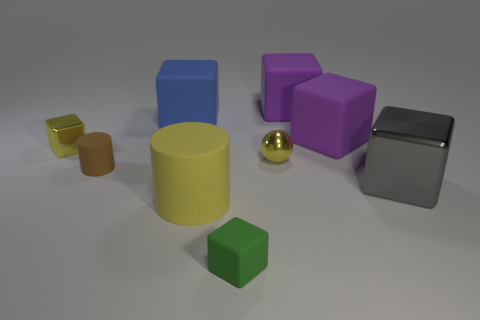Subtract all gray blocks. How many blocks are left? 5 Subtract all purple blocks. How many blocks are left? 4 Subtract all yellow cubes. Subtract all red spheres. How many cubes are left? 5 Add 1 tiny green things. How many objects exist? 10 Subtract all cylinders. How many objects are left? 7 Subtract all big blue cubes. Subtract all large yellow rubber cylinders. How many objects are left? 7 Add 4 brown cylinders. How many brown cylinders are left? 5 Add 4 large matte cubes. How many large matte cubes exist? 7 Subtract 0 cyan cubes. How many objects are left? 9 